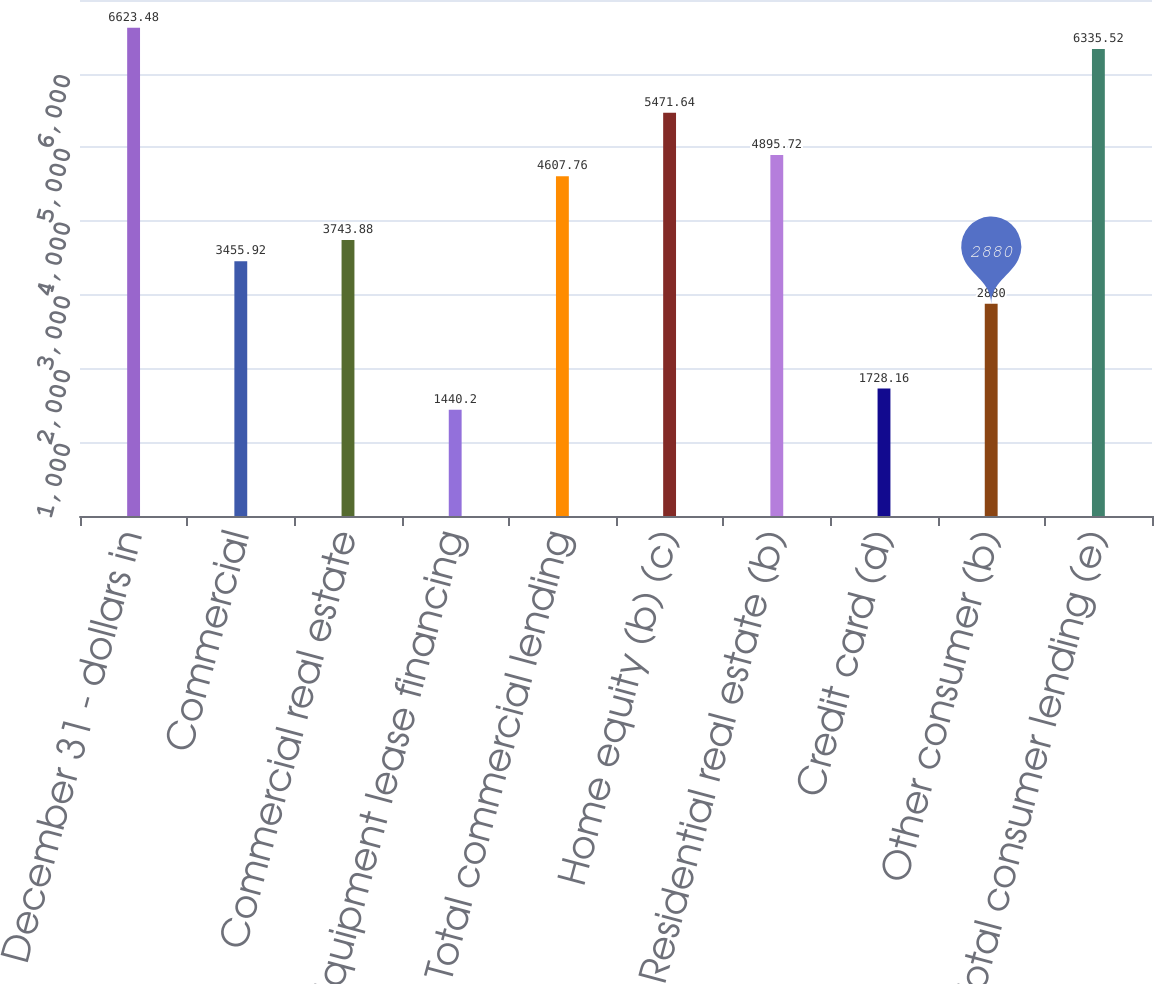Convert chart. <chart><loc_0><loc_0><loc_500><loc_500><bar_chart><fcel>December 31 - dollars in<fcel>Commercial<fcel>Commercial real estate<fcel>Equipment lease financing<fcel>Total commercial lending<fcel>Home equity (b) (c)<fcel>Residential real estate (b)<fcel>Credit card (d)<fcel>Other consumer (b)<fcel>Total consumer lending (e)<nl><fcel>6623.48<fcel>3455.92<fcel>3743.88<fcel>1440.2<fcel>4607.76<fcel>5471.64<fcel>4895.72<fcel>1728.16<fcel>2880<fcel>6335.52<nl></chart> 